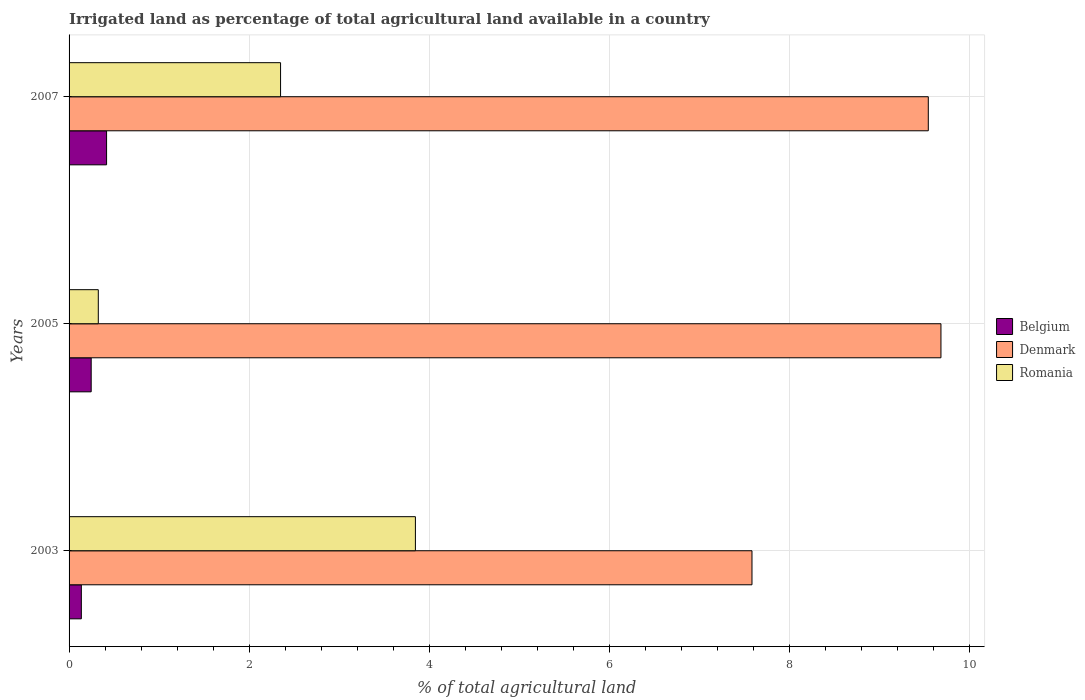Are the number of bars per tick equal to the number of legend labels?
Make the answer very short. Yes. Are the number of bars on each tick of the Y-axis equal?
Offer a very short reply. Yes. How many bars are there on the 1st tick from the top?
Offer a terse response. 3. How many bars are there on the 3rd tick from the bottom?
Make the answer very short. 3. What is the label of the 1st group of bars from the top?
Your answer should be compact. 2007. In how many cases, is the number of bars for a given year not equal to the number of legend labels?
Keep it short and to the point. 0. What is the percentage of irrigated land in Belgium in 2003?
Your response must be concise. 0.14. Across all years, what is the maximum percentage of irrigated land in Romania?
Your answer should be compact. 3.84. Across all years, what is the minimum percentage of irrigated land in Belgium?
Make the answer very short. 0.14. What is the total percentage of irrigated land in Belgium in the graph?
Give a very brief answer. 0.8. What is the difference between the percentage of irrigated land in Denmark in 2005 and that in 2007?
Keep it short and to the point. 0.14. What is the difference between the percentage of irrigated land in Romania in 2005 and the percentage of irrigated land in Denmark in 2003?
Offer a terse response. -7.26. What is the average percentage of irrigated land in Romania per year?
Give a very brief answer. 2.17. In the year 2005, what is the difference between the percentage of irrigated land in Belgium and percentage of irrigated land in Denmark?
Offer a terse response. -9.43. What is the ratio of the percentage of irrigated land in Belgium in 2005 to that in 2007?
Your answer should be very brief. 0.59. Is the percentage of irrigated land in Denmark in 2005 less than that in 2007?
Give a very brief answer. No. What is the difference between the highest and the second highest percentage of irrigated land in Romania?
Offer a terse response. 1.5. What is the difference between the highest and the lowest percentage of irrigated land in Belgium?
Offer a very short reply. 0.28. Is the sum of the percentage of irrigated land in Belgium in 2005 and 2007 greater than the maximum percentage of irrigated land in Denmark across all years?
Make the answer very short. No. Are all the bars in the graph horizontal?
Provide a short and direct response. Yes. How many years are there in the graph?
Your answer should be compact. 3. What is the difference between two consecutive major ticks on the X-axis?
Give a very brief answer. 2. Are the values on the major ticks of X-axis written in scientific E-notation?
Make the answer very short. No. Does the graph contain grids?
Your response must be concise. Yes. Where does the legend appear in the graph?
Keep it short and to the point. Center right. How many legend labels are there?
Your answer should be very brief. 3. What is the title of the graph?
Offer a terse response. Irrigated land as percentage of total agricultural land available in a country. What is the label or title of the X-axis?
Your answer should be very brief. % of total agricultural land. What is the label or title of the Y-axis?
Your answer should be compact. Years. What is the % of total agricultural land in Belgium in 2003?
Provide a succinct answer. 0.14. What is the % of total agricultural land in Denmark in 2003?
Your response must be concise. 7.58. What is the % of total agricultural land of Romania in 2003?
Offer a terse response. 3.84. What is the % of total agricultural land in Belgium in 2005?
Give a very brief answer. 0.25. What is the % of total agricultural land in Denmark in 2005?
Provide a short and direct response. 9.68. What is the % of total agricultural land of Romania in 2005?
Provide a short and direct response. 0.32. What is the % of total agricultural land in Belgium in 2007?
Give a very brief answer. 0.42. What is the % of total agricultural land in Denmark in 2007?
Keep it short and to the point. 9.54. What is the % of total agricultural land in Romania in 2007?
Provide a succinct answer. 2.35. Across all years, what is the maximum % of total agricultural land in Belgium?
Give a very brief answer. 0.42. Across all years, what is the maximum % of total agricultural land of Denmark?
Offer a terse response. 9.68. Across all years, what is the maximum % of total agricultural land in Romania?
Offer a very short reply. 3.84. Across all years, what is the minimum % of total agricultural land in Belgium?
Keep it short and to the point. 0.14. Across all years, what is the minimum % of total agricultural land of Denmark?
Ensure brevity in your answer.  7.58. Across all years, what is the minimum % of total agricultural land of Romania?
Make the answer very short. 0.32. What is the total % of total agricultural land in Belgium in the graph?
Your response must be concise. 0.8. What is the total % of total agricultural land in Denmark in the graph?
Make the answer very short. 26.8. What is the total % of total agricultural land of Romania in the graph?
Offer a very short reply. 6.52. What is the difference between the % of total agricultural land in Belgium in 2003 and that in 2005?
Provide a short and direct response. -0.11. What is the difference between the % of total agricultural land in Denmark in 2003 and that in 2005?
Keep it short and to the point. -2.1. What is the difference between the % of total agricultural land in Romania in 2003 and that in 2005?
Provide a short and direct response. 3.52. What is the difference between the % of total agricultural land of Belgium in 2003 and that in 2007?
Provide a short and direct response. -0.28. What is the difference between the % of total agricultural land of Denmark in 2003 and that in 2007?
Your response must be concise. -1.96. What is the difference between the % of total agricultural land of Romania in 2003 and that in 2007?
Offer a very short reply. 1.5. What is the difference between the % of total agricultural land of Belgium in 2005 and that in 2007?
Your answer should be compact. -0.17. What is the difference between the % of total agricultural land of Denmark in 2005 and that in 2007?
Offer a very short reply. 0.14. What is the difference between the % of total agricultural land of Romania in 2005 and that in 2007?
Make the answer very short. -2.02. What is the difference between the % of total agricultural land of Belgium in 2003 and the % of total agricultural land of Denmark in 2005?
Make the answer very short. -9.54. What is the difference between the % of total agricultural land of Belgium in 2003 and the % of total agricultural land of Romania in 2005?
Give a very brief answer. -0.19. What is the difference between the % of total agricultural land in Denmark in 2003 and the % of total agricultural land in Romania in 2005?
Make the answer very short. 7.26. What is the difference between the % of total agricultural land in Belgium in 2003 and the % of total agricultural land in Denmark in 2007?
Make the answer very short. -9.4. What is the difference between the % of total agricultural land in Belgium in 2003 and the % of total agricultural land in Romania in 2007?
Provide a short and direct response. -2.21. What is the difference between the % of total agricultural land of Denmark in 2003 and the % of total agricultural land of Romania in 2007?
Ensure brevity in your answer.  5.23. What is the difference between the % of total agricultural land of Belgium in 2005 and the % of total agricultural land of Denmark in 2007?
Your answer should be very brief. -9.29. What is the difference between the % of total agricultural land in Belgium in 2005 and the % of total agricultural land in Romania in 2007?
Provide a succinct answer. -2.1. What is the difference between the % of total agricultural land of Denmark in 2005 and the % of total agricultural land of Romania in 2007?
Give a very brief answer. 7.33. What is the average % of total agricultural land of Belgium per year?
Offer a very short reply. 0.27. What is the average % of total agricultural land of Denmark per year?
Keep it short and to the point. 8.93. What is the average % of total agricultural land in Romania per year?
Make the answer very short. 2.17. In the year 2003, what is the difference between the % of total agricultural land of Belgium and % of total agricultural land of Denmark?
Your answer should be very brief. -7.44. In the year 2003, what is the difference between the % of total agricultural land in Belgium and % of total agricultural land in Romania?
Give a very brief answer. -3.71. In the year 2003, what is the difference between the % of total agricultural land in Denmark and % of total agricultural land in Romania?
Offer a very short reply. 3.74. In the year 2005, what is the difference between the % of total agricultural land in Belgium and % of total agricultural land in Denmark?
Your response must be concise. -9.43. In the year 2005, what is the difference between the % of total agricultural land of Belgium and % of total agricultural land of Romania?
Your answer should be compact. -0.08. In the year 2005, what is the difference between the % of total agricultural land in Denmark and % of total agricultural land in Romania?
Your answer should be compact. 9.35. In the year 2007, what is the difference between the % of total agricultural land in Belgium and % of total agricultural land in Denmark?
Provide a succinct answer. -9.12. In the year 2007, what is the difference between the % of total agricultural land of Belgium and % of total agricultural land of Romania?
Give a very brief answer. -1.93. In the year 2007, what is the difference between the % of total agricultural land in Denmark and % of total agricultural land in Romania?
Keep it short and to the point. 7.19. What is the ratio of the % of total agricultural land of Belgium in 2003 to that in 2005?
Ensure brevity in your answer.  0.56. What is the ratio of the % of total agricultural land of Denmark in 2003 to that in 2005?
Provide a short and direct response. 0.78. What is the ratio of the % of total agricultural land in Romania in 2003 to that in 2005?
Offer a very short reply. 11.85. What is the ratio of the % of total agricultural land in Belgium in 2003 to that in 2007?
Offer a very short reply. 0.33. What is the ratio of the % of total agricultural land in Denmark in 2003 to that in 2007?
Make the answer very short. 0.79. What is the ratio of the % of total agricultural land in Romania in 2003 to that in 2007?
Offer a very short reply. 1.64. What is the ratio of the % of total agricultural land of Belgium in 2005 to that in 2007?
Your response must be concise. 0.59. What is the ratio of the % of total agricultural land of Denmark in 2005 to that in 2007?
Make the answer very short. 1.01. What is the ratio of the % of total agricultural land of Romania in 2005 to that in 2007?
Your answer should be very brief. 0.14. What is the difference between the highest and the second highest % of total agricultural land in Belgium?
Give a very brief answer. 0.17. What is the difference between the highest and the second highest % of total agricultural land in Denmark?
Make the answer very short. 0.14. What is the difference between the highest and the second highest % of total agricultural land in Romania?
Your answer should be compact. 1.5. What is the difference between the highest and the lowest % of total agricultural land of Belgium?
Your response must be concise. 0.28. What is the difference between the highest and the lowest % of total agricultural land of Denmark?
Provide a succinct answer. 2.1. What is the difference between the highest and the lowest % of total agricultural land of Romania?
Ensure brevity in your answer.  3.52. 